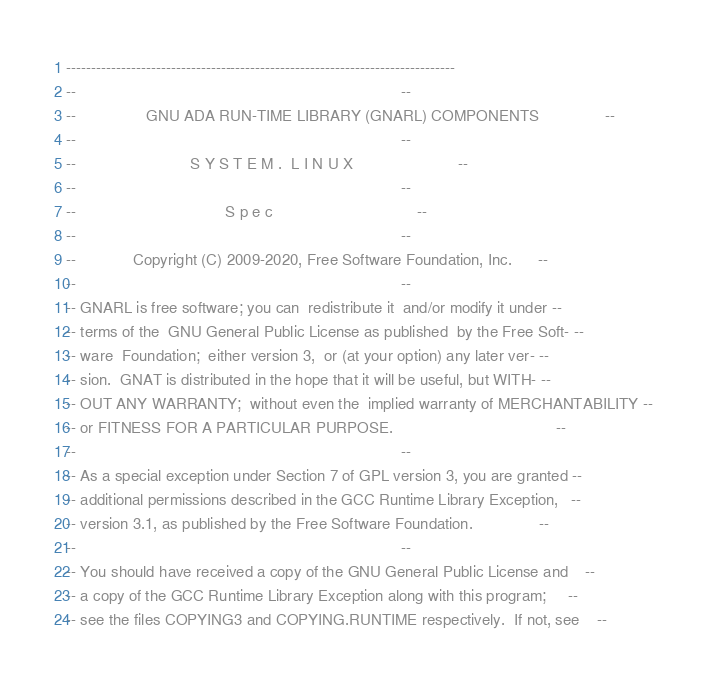Convert code to text. <code><loc_0><loc_0><loc_500><loc_500><_Ada_>------------------------------------------------------------------------------
--                                                                          --
--                GNU ADA RUN-TIME LIBRARY (GNARL) COMPONENTS               --
--                                                                          --
--                          S Y S T E M .  L I N U X                        --
--                                                                          --
--                                  S p e c                                 --
--                                                                          --
--             Copyright (C) 2009-2020, Free Software Foundation, Inc.      --
--                                                                          --
-- GNARL is free software; you can  redistribute it  and/or modify it under --
-- terms of the  GNU General Public License as published  by the Free Soft- --
-- ware  Foundation;  either version 3,  or (at your option) any later ver- --
-- sion.  GNAT is distributed in the hope that it will be useful, but WITH- --
-- OUT ANY WARRANTY;  without even the  implied warranty of MERCHANTABILITY --
-- or FITNESS FOR A PARTICULAR PURPOSE.                                     --
--                                                                          --
-- As a special exception under Section 7 of GPL version 3, you are granted --
-- additional permissions described in the GCC Runtime Library Exception,   --
-- version 3.1, as published by the Free Software Foundation.               --
--                                                                          --
-- You should have received a copy of the GNU General Public License and    --
-- a copy of the GCC Runtime Library Exception along with this program;     --
-- see the files COPYING3 and COPYING.RUNTIME respectively.  If not, see    --</code> 